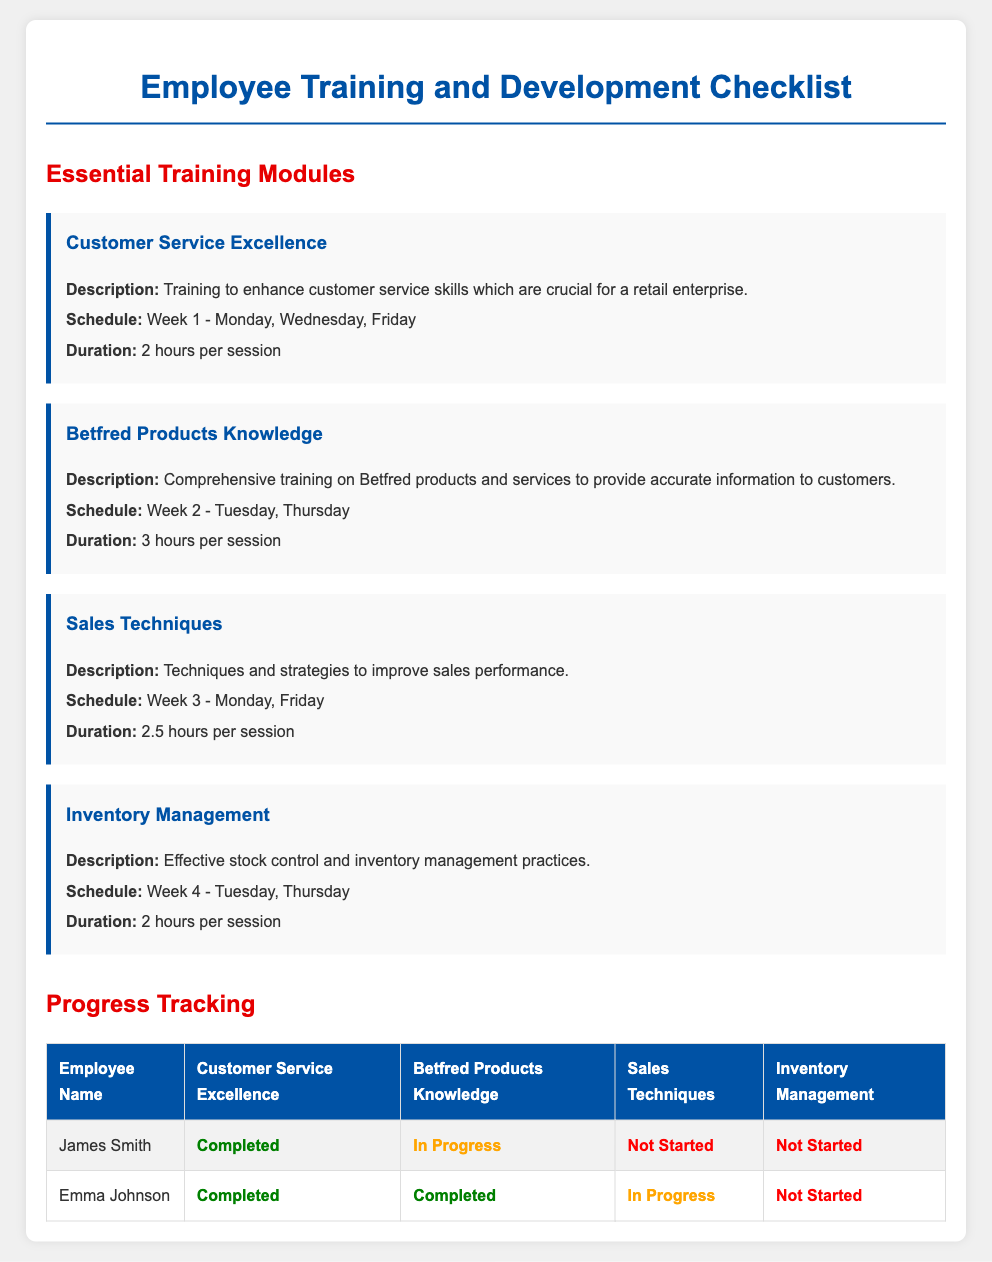What is the title of the document? The title of the document is indicated at the top and is "Employee Training and Development Checklist."
Answer: Employee Training and Development Checklist What is the first training module listed? The first training module is the first one mentioned under "Essential Training Modules" in the document.
Answer: Customer Service Excellence How many hours is the Betfred Products Knowledge training session? The duration of the Betfred Products Knowledge session is specified in the description of that module.
Answer: 3 hours What day of the week is the Inventory Management training scheduled? The schedule mentions which days Inventory Management sessions take place, found in its respective module.
Answer: Tuesday, Thursday How many employees have completed the Customer Service Excellence training? The table summarizes the completion status of the training for each employee listed under the module.
Answer: 2 What status is associated with Emma Johnson for the Sales Techniques training? The document provides the completion status of different training modules for each employee.
Answer: In Progress Which training module has the longest duration? The durations of each module are compared to determine which is the longest, found in the descriptions.
Answer: Betfred Products Knowledge Which employee has not started the Inventory Management training? The table lists the status of each employee's training progress, indicating who has not started.
Answer: James Smith What color indicates the 'In Progress' status in the document? The document uses specific colors to indicate status, which is explained through the provided style.
Answer: Orange 